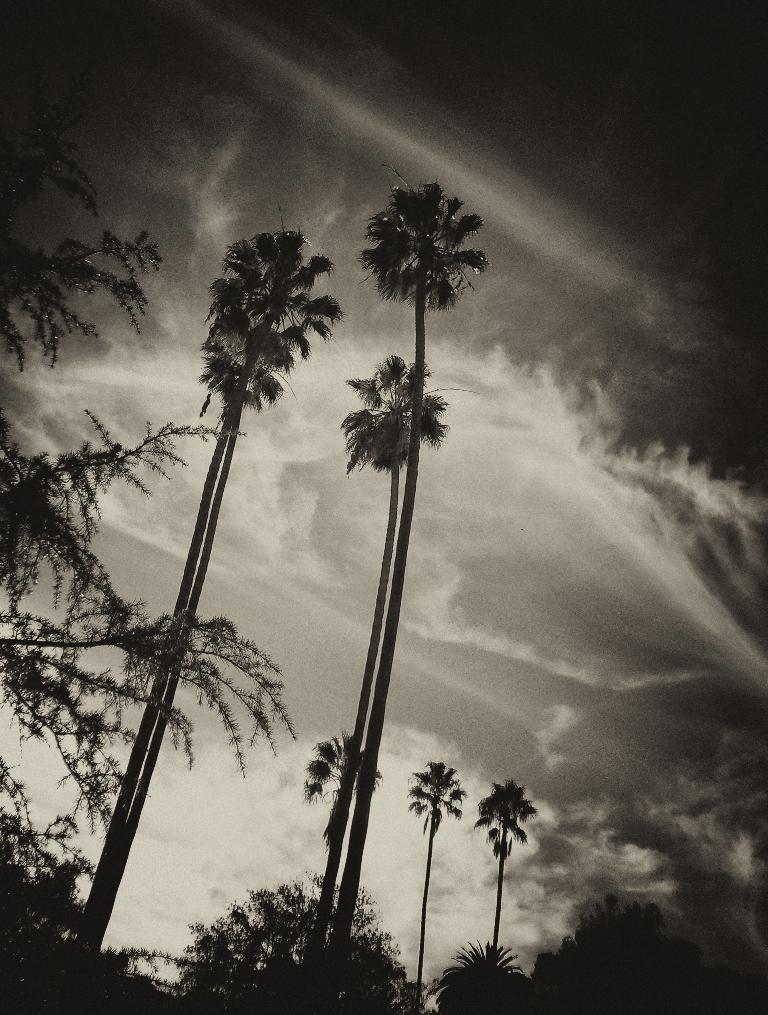Please provide a concise description of this image. In the picture I can see trees. In the background I can see the sky. This picture is black and white in color. 